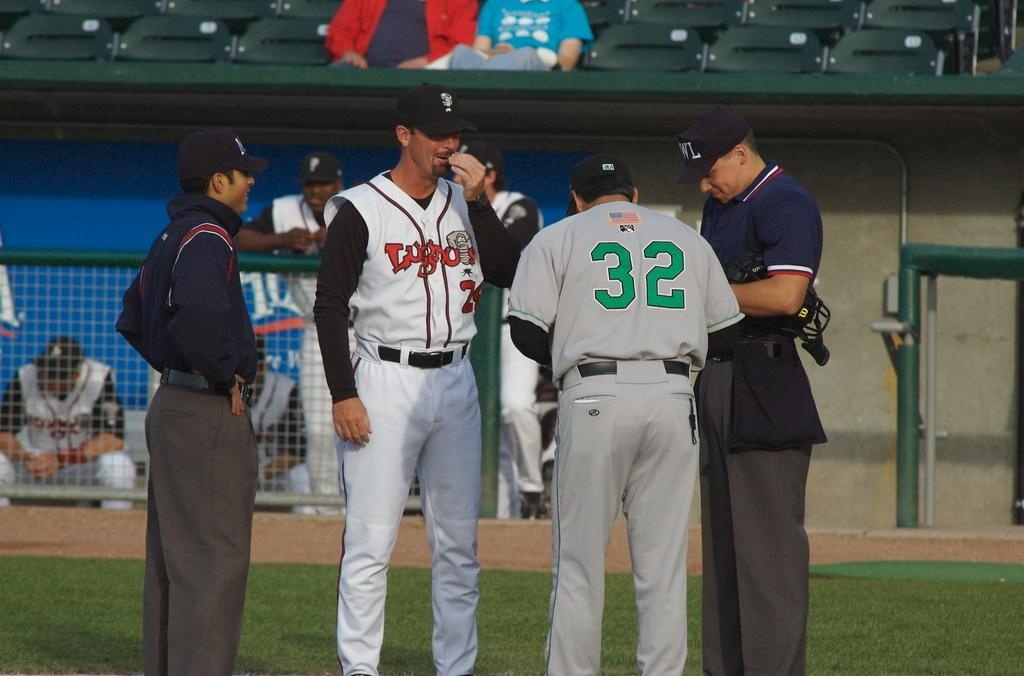<image>
Relay a brief, clear account of the picture shown. Baseball player wearing number 32 talking to another man. 